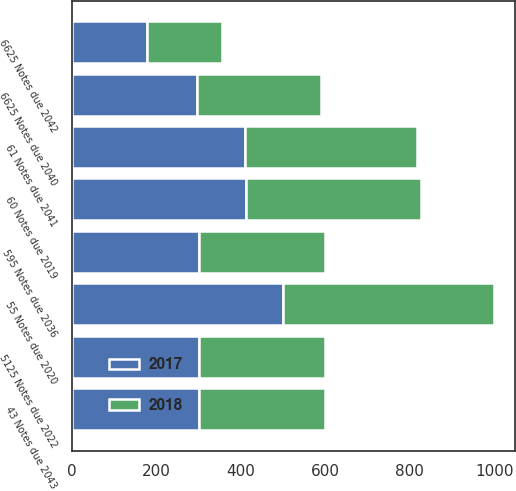<chart> <loc_0><loc_0><loc_500><loc_500><stacked_bar_chart><ecel><fcel>60 Notes due 2019<fcel>55 Notes due 2020<fcel>5125 Notes due 2022<fcel>595 Notes due 2036<fcel>6625 Notes due 2040<fcel>61 Notes due 2041<fcel>6625 Notes due 2042<fcel>43 Notes due 2043<nl><fcel>2017<fcel>413<fcel>500<fcel>300<fcel>300<fcel>295<fcel>409<fcel>178<fcel>300<nl><fcel>2018<fcel>413<fcel>500<fcel>300<fcel>300<fcel>295<fcel>409<fcel>178<fcel>300<nl></chart> 